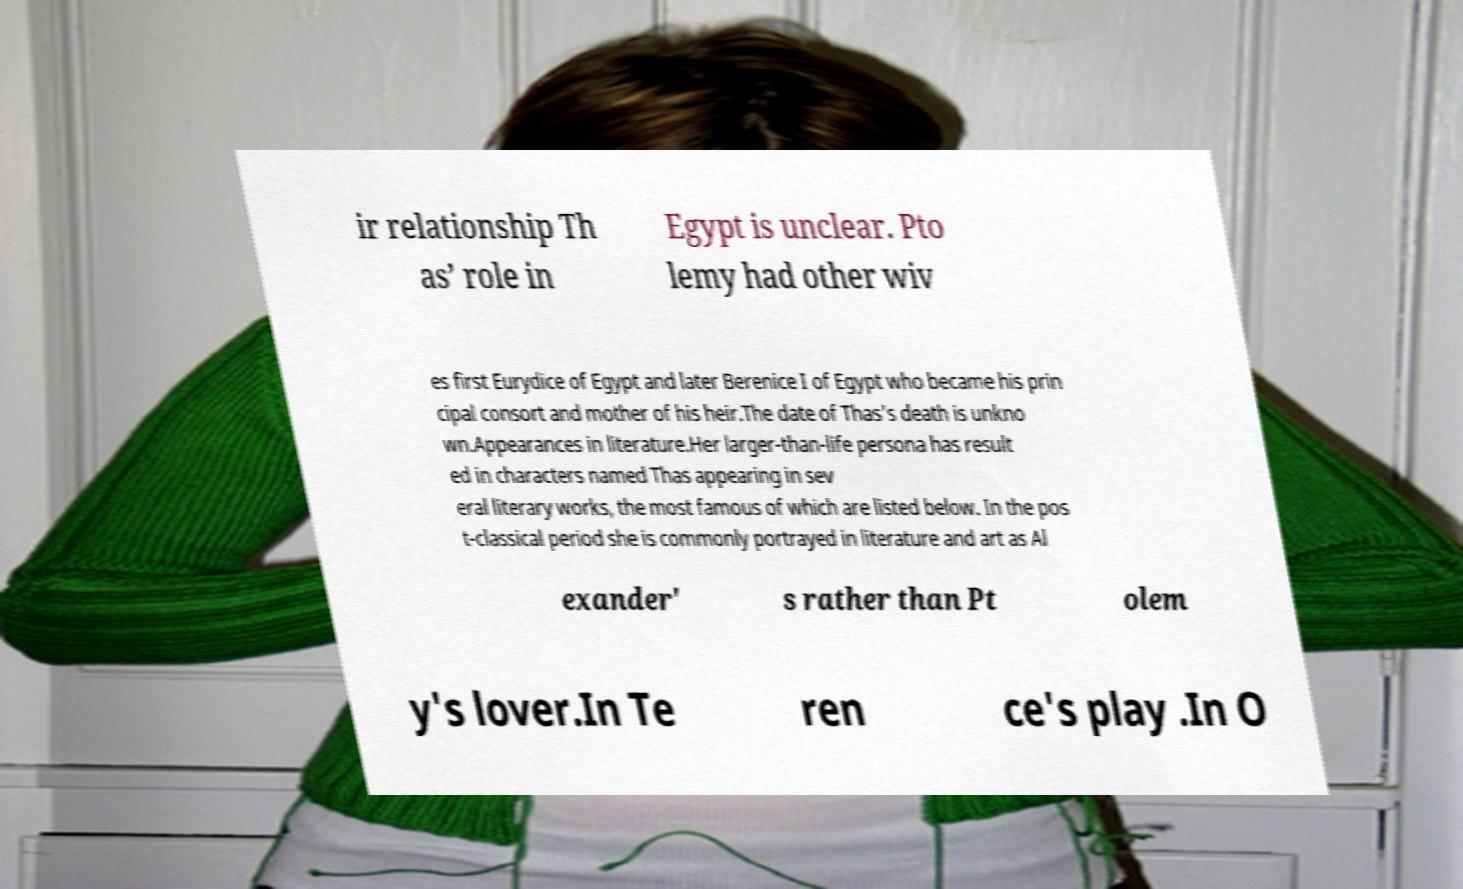Please read and relay the text visible in this image. What does it say? ir relationship Th as’ role in Egypt is unclear. Pto lemy had other wiv es first Eurydice of Egypt and later Berenice I of Egypt who became his prin cipal consort and mother of his heir.The date of Thas's death is unkno wn.Appearances in literature.Her larger-than-life persona has result ed in characters named Thas appearing in sev eral literary works, the most famous of which are listed below. In the pos t-classical period she is commonly portrayed in literature and art as Al exander' s rather than Pt olem y's lover.In Te ren ce's play .In O 